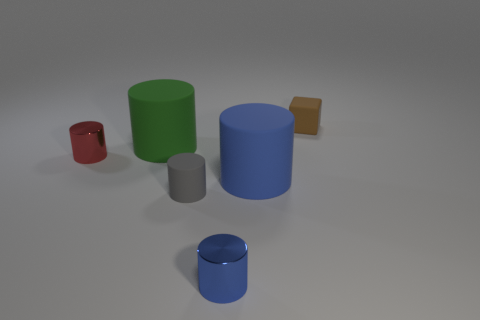Subtract all red cylinders. How many cylinders are left? 4 Subtract all purple cylinders. Subtract all red blocks. How many cylinders are left? 5 Add 2 gray cylinders. How many objects exist? 8 Subtract all cylinders. How many objects are left? 1 Add 1 small blue things. How many small blue things are left? 2 Add 5 large purple metallic spheres. How many large purple metallic spheres exist? 5 Subtract 0 cyan balls. How many objects are left? 6 Subtract all purple shiny cylinders. Subtract all blue metallic objects. How many objects are left? 5 